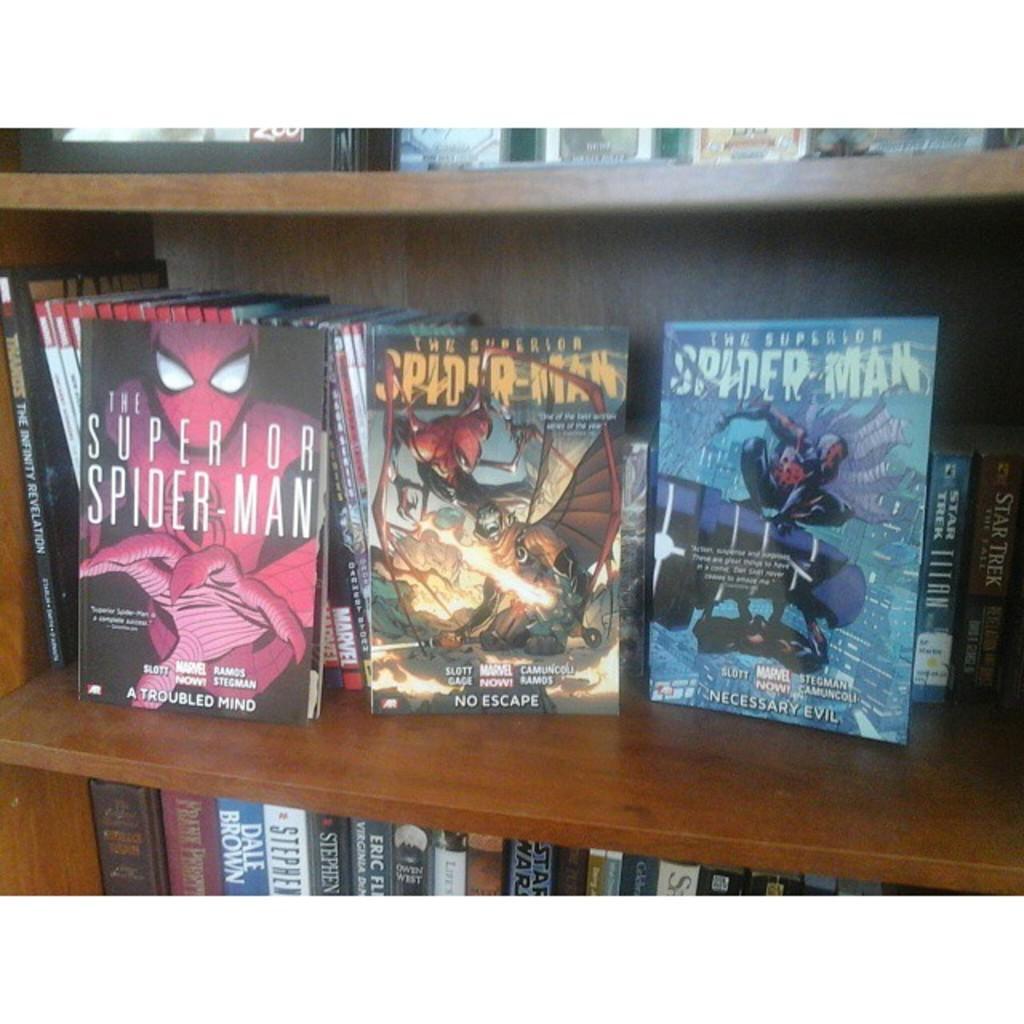How would you summarize this image in a sentence or two? In this image, we can see a rack contains some books. 